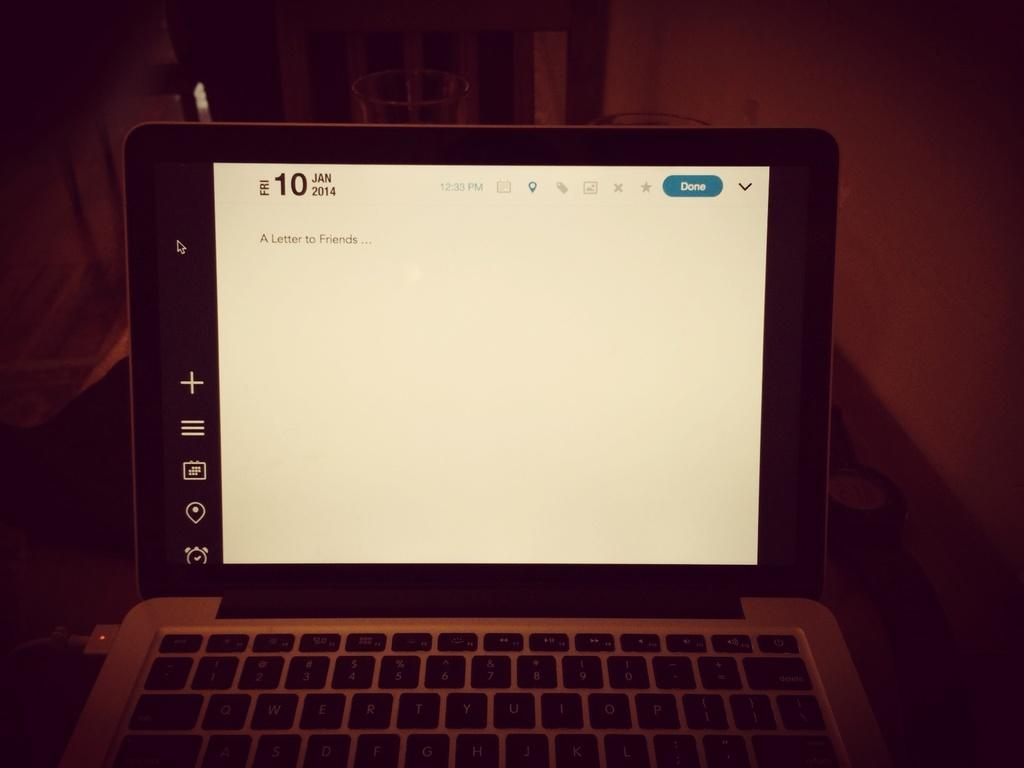<image>
Offer a succinct explanation of the picture presented. A computer monitor is lit up with the date 10 Jan 2014 on top. 